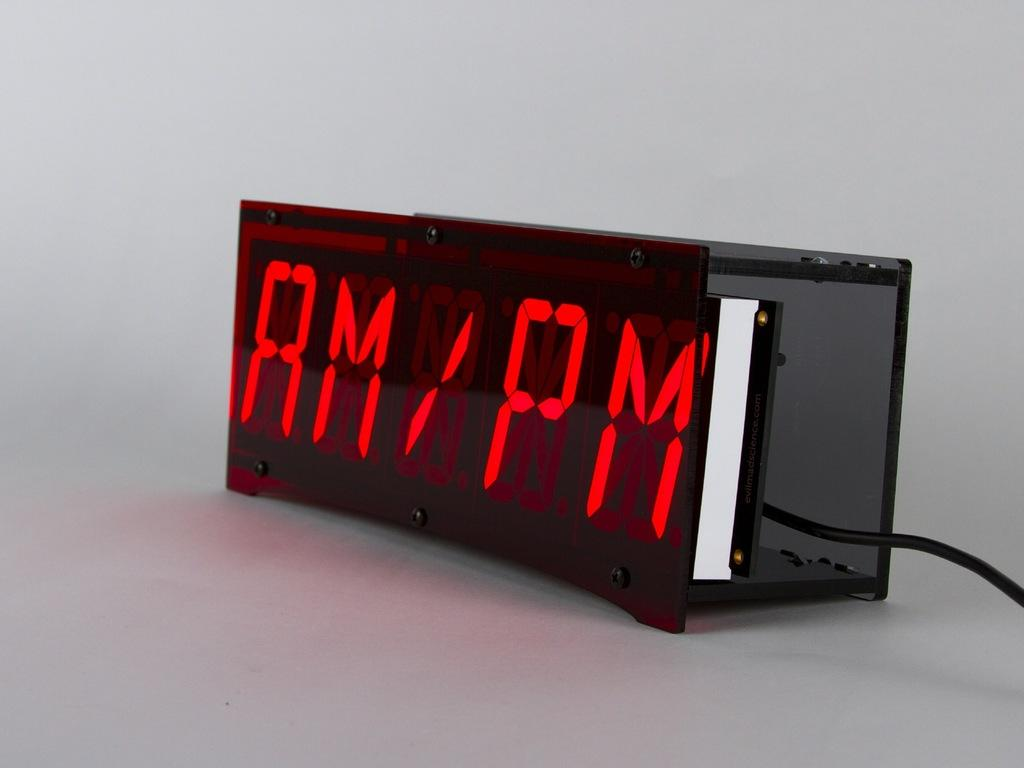Provide a one-sentence caption for the provided image. A digital clock with "AM/PM" on the display. 